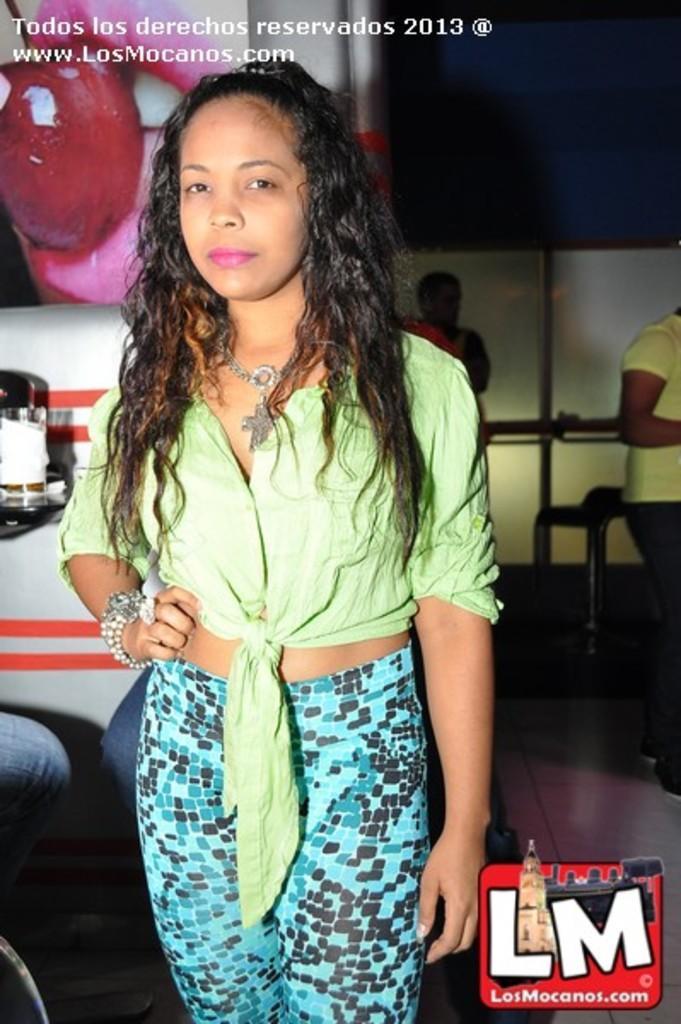Please provide a concise description of this image. In this image, we can see person standing and wearing clothes. There is a logo in the bottom right of the image. There is an another person on the right side of the image. 